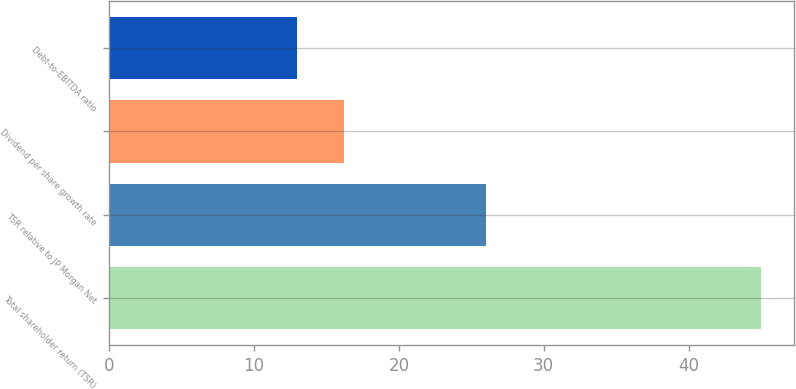Convert chart to OTSL. <chart><loc_0><loc_0><loc_500><loc_500><bar_chart><fcel>Total shareholder return (TSR)<fcel>TSR relative to JP Morgan Net<fcel>Dividend per share growth rate<fcel>Debt-to-EBITDA ratio<nl><fcel>45<fcel>26<fcel>16.2<fcel>13<nl></chart> 